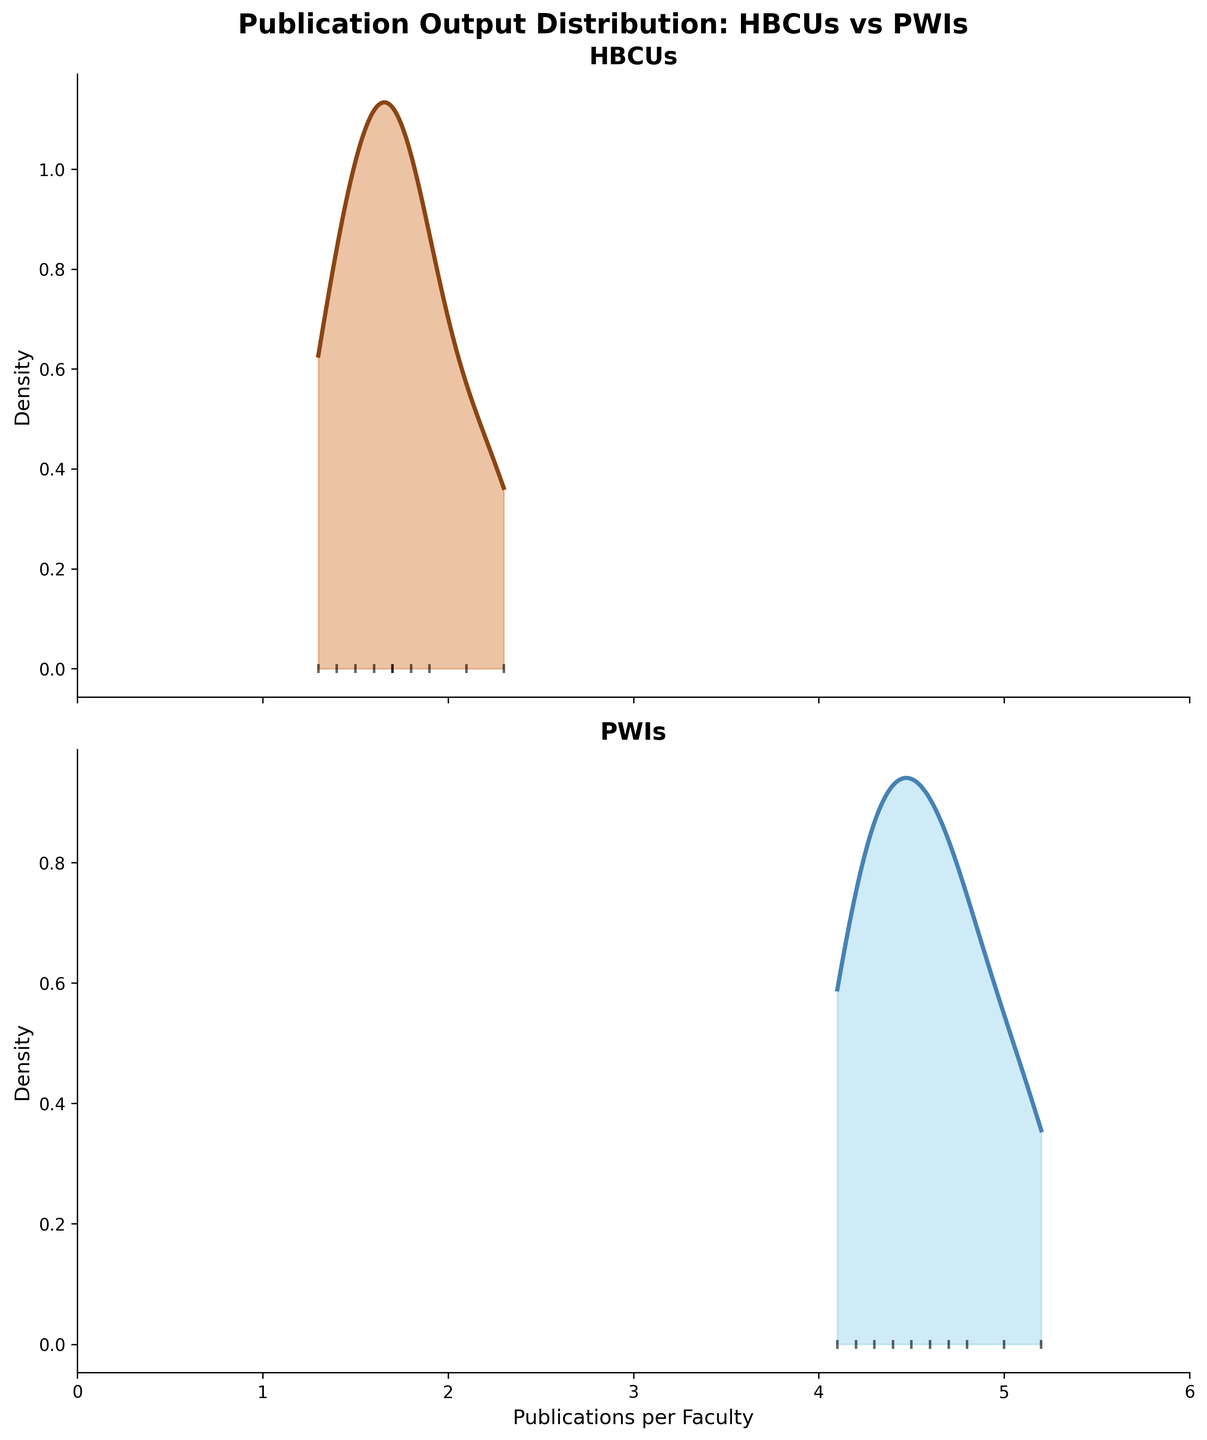Which institution type has the broader range of publication output per faculty? To determine the range, we observe the x-axis limits and the spread of each density plot. HBCUs have publication outputs spanning from around 1.3 to 2.3 publications per faculty, while PWIs' publication outputs range from 4.1 to 5.2 publications per faculty. Both spans are equal, but we have more data points in HBCUs
Answer: Both have equal range, but more data points in HBCUs What is the maximum publication output per faculty observed for PWIs? By looking at the scatter plot points within the PWI density plot, the highest point on the x-axis is labeled 5.2 publications per faculty, which corresponds to Harvard University
Answer: 5.2 publications How does the peak density of HBCUs compare to that of PWIs? Comparing the density plots' peak heights, the peak of the HBCUs appears lower and wider, indicating a broader but less dense distribution, whereas the peak of the PWIs is higher and narrower, indicating a more concentrated distribution
Answer: HBCUs have a lower and wider peak; PWIs have a higher and narrower peak Which institution type has a higher average publication rate per faculty? To deduce the average, we should consider the concentration and spread of the plots. The mean publication rate for PWIs appears around 4.6 to 5.0, while for HBCUs it is lower, around 1.5 to 2.3. Hence, PWIs have a higher average
Answer: PWIs Are there any HBCUs with a publication output greater than 3 publications per faculty? By examining the scatter plot points over the HBCUs density plot, the highest publication output is 2.3, which is below 3 publications per faculty
Answer: No What title is given to the overall figure? The title is displayed at the top of the figure and reads "Publication Output Distribution: HBCUs vs PWIs," indicating the subject matter and comparison groups
Answer: Publication Output Distribution: HBCUs vs PWIs Between HBCUs and PWIs, which group shows a more varied publication output per faculty? By looking at the spread and range of data points in each density plot, HBCUs show a wider spread between 1.3 and 2.3 publications per faculty, whereas PWIs are more concentrated between 4.1 and 5.2
Answer: HBCUs show a more varied output How does the distribution shape of the publication outputs differ between HBCUs and PWIs? The density plot for HBCUs shows a flatter, more uniform distribution, while the PWIs reveal a more peaked distribution, indicating a higher concentration around their mean
Answer: HBCUs are flatter and more uniform; PWIs are more peaked and concentrated 